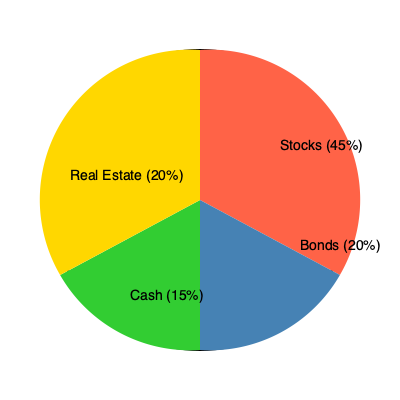Based on the pie chart showing the asset allocation in your 529 plan, which investment type makes up the largest portion of your savings? To determine which investment type makes up the largest portion of the 529 plan savings, we need to compare the percentages for each asset class shown in the pie chart:

1. Stocks: 45%
2. Bonds: 20%
3. Cash: 15%
4. Real Estate: 20%

By comparing these percentages, we can see that stocks have the highest percentage at 45%. This means that stocks make up the largest portion of the 529 plan savings.

The pie chart visually represents this information, with stocks occupying the largest slice (in red) of the circular graph.
Answer: Stocks 